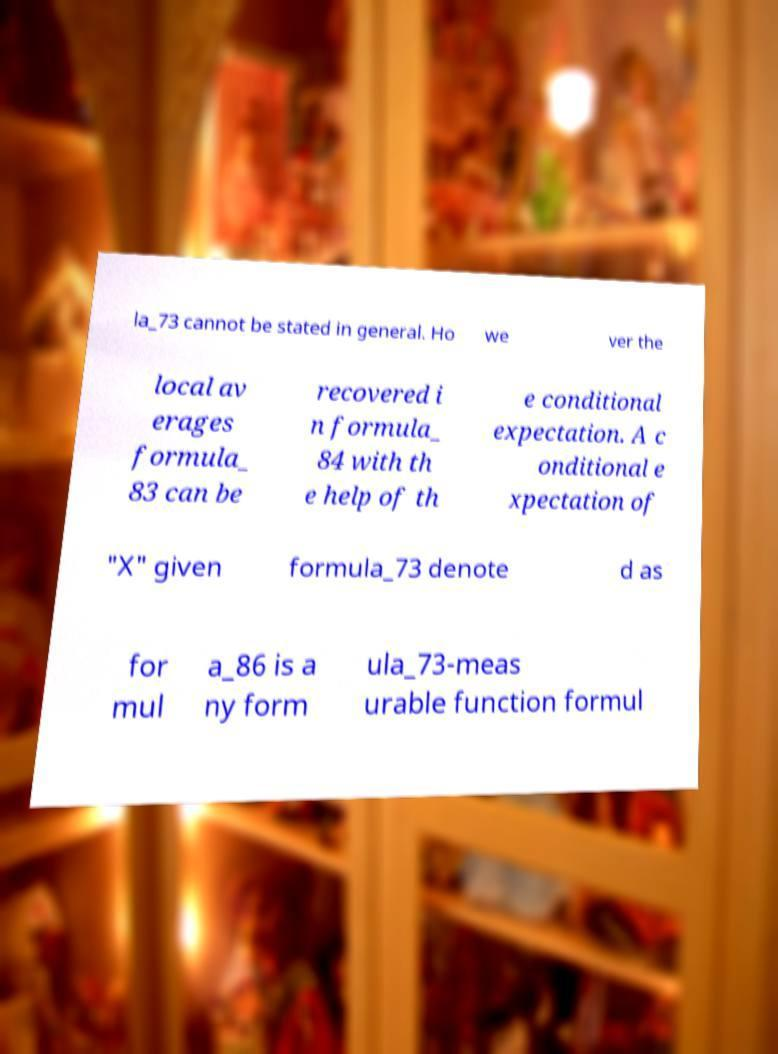I need the written content from this picture converted into text. Can you do that? la_73 cannot be stated in general. Ho we ver the local av erages formula_ 83 can be recovered i n formula_ 84 with th e help of th e conditional expectation. A c onditional e xpectation of "X" given formula_73 denote d as for mul a_86 is a ny form ula_73-meas urable function formul 